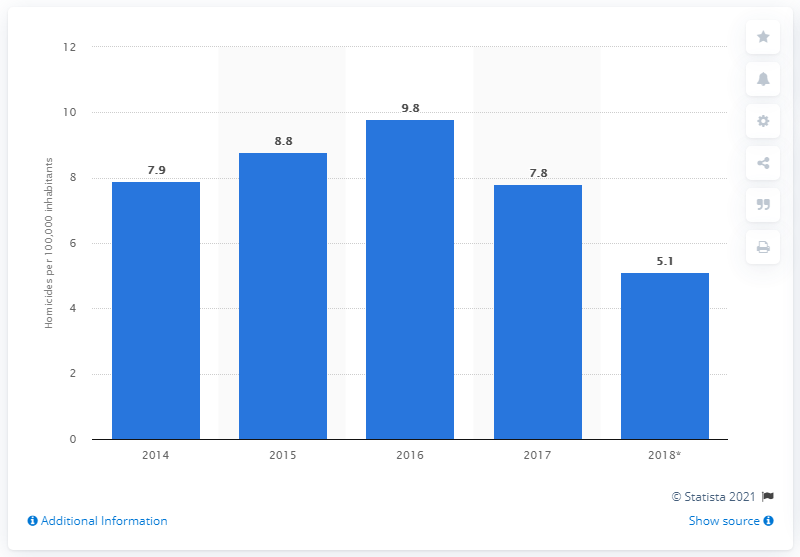Point out several critical features in this image. In 2018, the homicide rate in Paraguay was 5.1 per 100,000 inhabitants. 